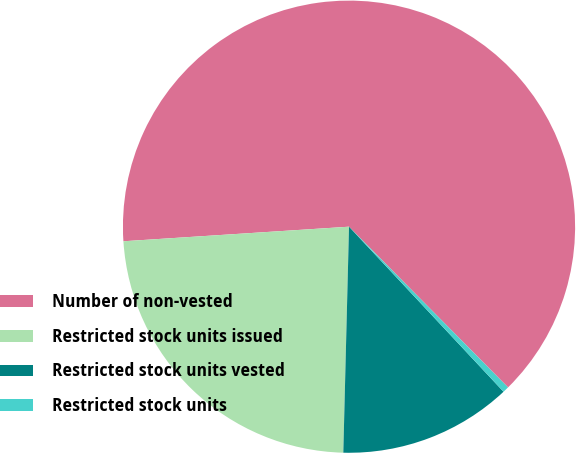Convert chart. <chart><loc_0><loc_0><loc_500><loc_500><pie_chart><fcel>Number of non-vested<fcel>Restricted stock units issued<fcel>Restricted stock units vested<fcel>Restricted stock units<nl><fcel>63.61%<fcel>23.57%<fcel>12.38%<fcel>0.44%<nl></chart> 